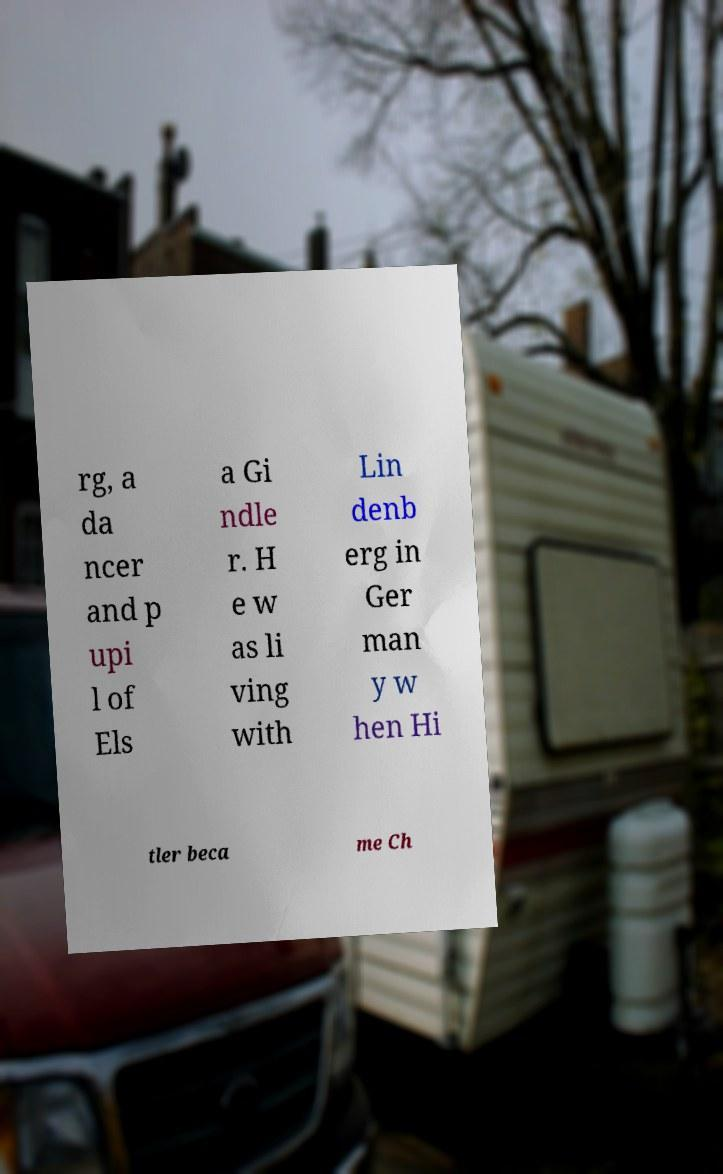For documentation purposes, I need the text within this image transcribed. Could you provide that? rg, a da ncer and p upi l of Els a Gi ndle r. H e w as li ving with Lin denb erg in Ger man y w hen Hi tler beca me Ch 